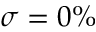<formula> <loc_0><loc_0><loc_500><loc_500>\sigma = 0 \%</formula> 